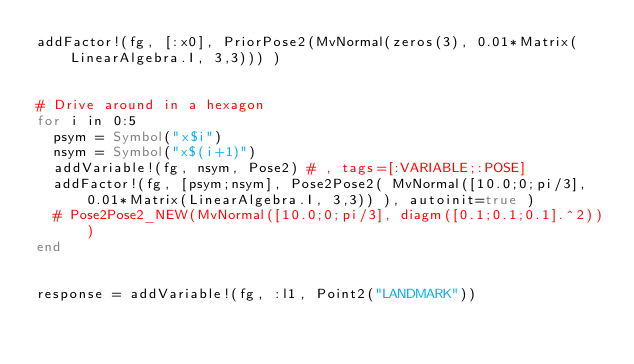<code> <loc_0><loc_0><loc_500><loc_500><_Julia_>addFactor!(fg, [:x0], PriorPose2(MvNormal(zeros(3), 0.01*Matrix(LinearAlgebra.I, 3,3))) )


# Drive around in a hexagon
for i in 0:5
  psym = Symbol("x$i")
  nsym = Symbol("x$(i+1)")
  addVariable!(fg, nsym, Pose2) # , tags=[:VARIABLE;:POSE]
  addFactor!(fg, [psym;nsym], Pose2Pose2( MvNormal([10.0;0;pi/3], 0.01*Matrix(LinearAlgebra.I, 3,3)) ), autoinit=true )
  # Pose2Pose2_NEW(MvNormal([10.0;0;pi/3], diagm([0.1;0.1;0.1].^2)))
end


response = addVariable!(fg, :l1, Point2("LANDMARK"))
</code> 